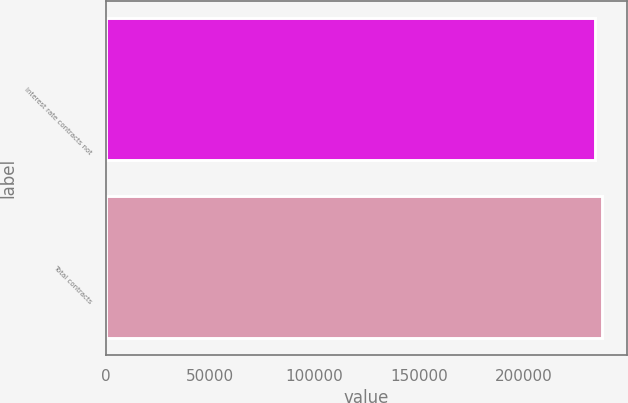<chart> <loc_0><loc_0><loc_500><loc_500><bar_chart><fcel>Interest rate contracts not<fcel>Total contracts<nl><fcel>234026<fcel>237490<nl></chart> 